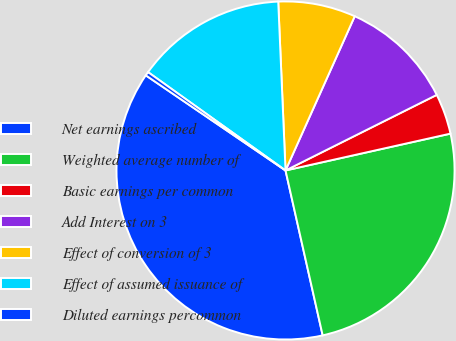Convert chart. <chart><loc_0><loc_0><loc_500><loc_500><pie_chart><fcel>Net earnings ascribed<fcel>Weighted average number of<fcel>Basic earnings per common<fcel>Add Interest on 3<fcel>Effect of conversion of 3<fcel>Effect of assumed issuance of<fcel>Diluted earnings percommon<nl><fcel>38.04%<fcel>24.97%<fcel>3.88%<fcel>10.91%<fcel>7.4%<fcel>14.43%<fcel>0.37%<nl></chart> 